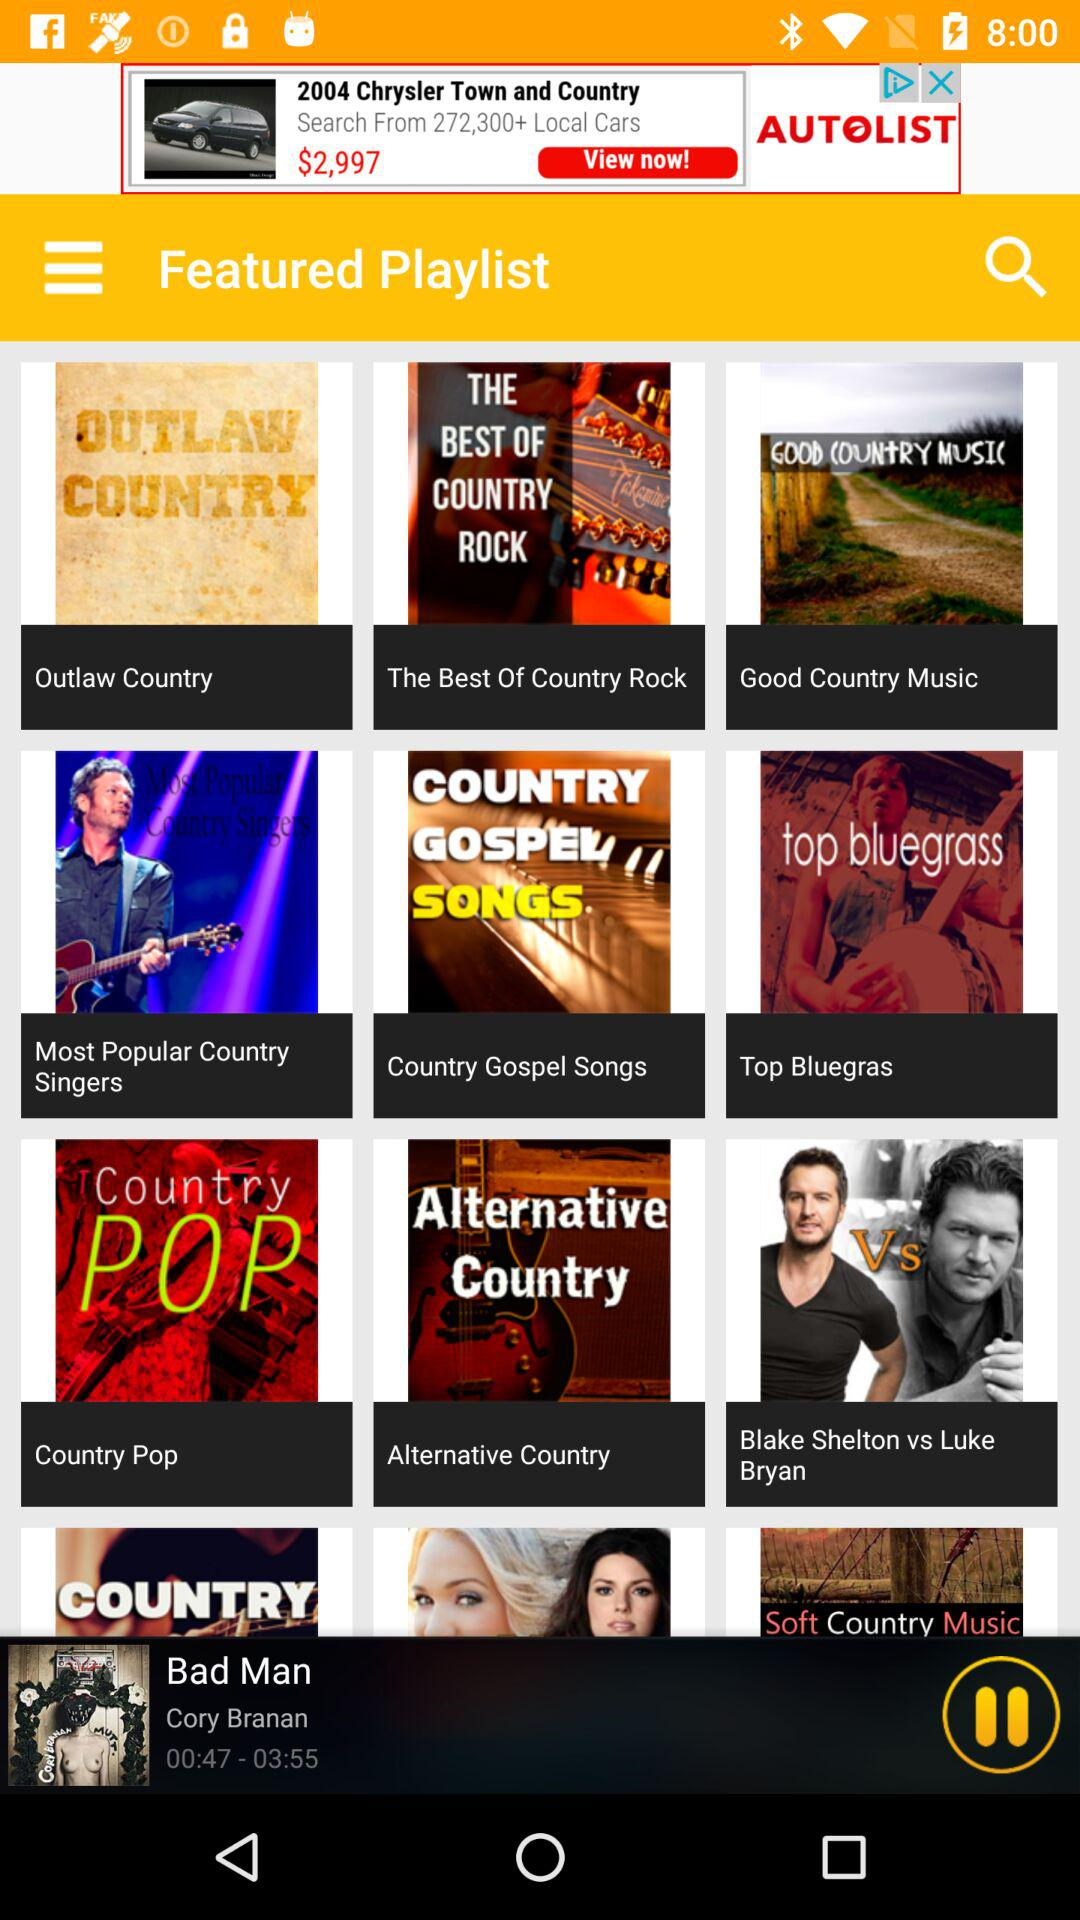Who is the singer of the best of country rock?
When the provided information is insufficient, respond with <no answer>. <no answer> 